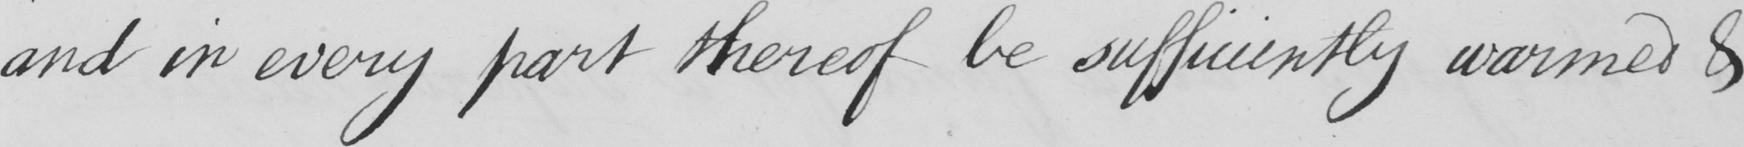What does this handwritten line say? and in ever part thereof be sufficiently warmed & 